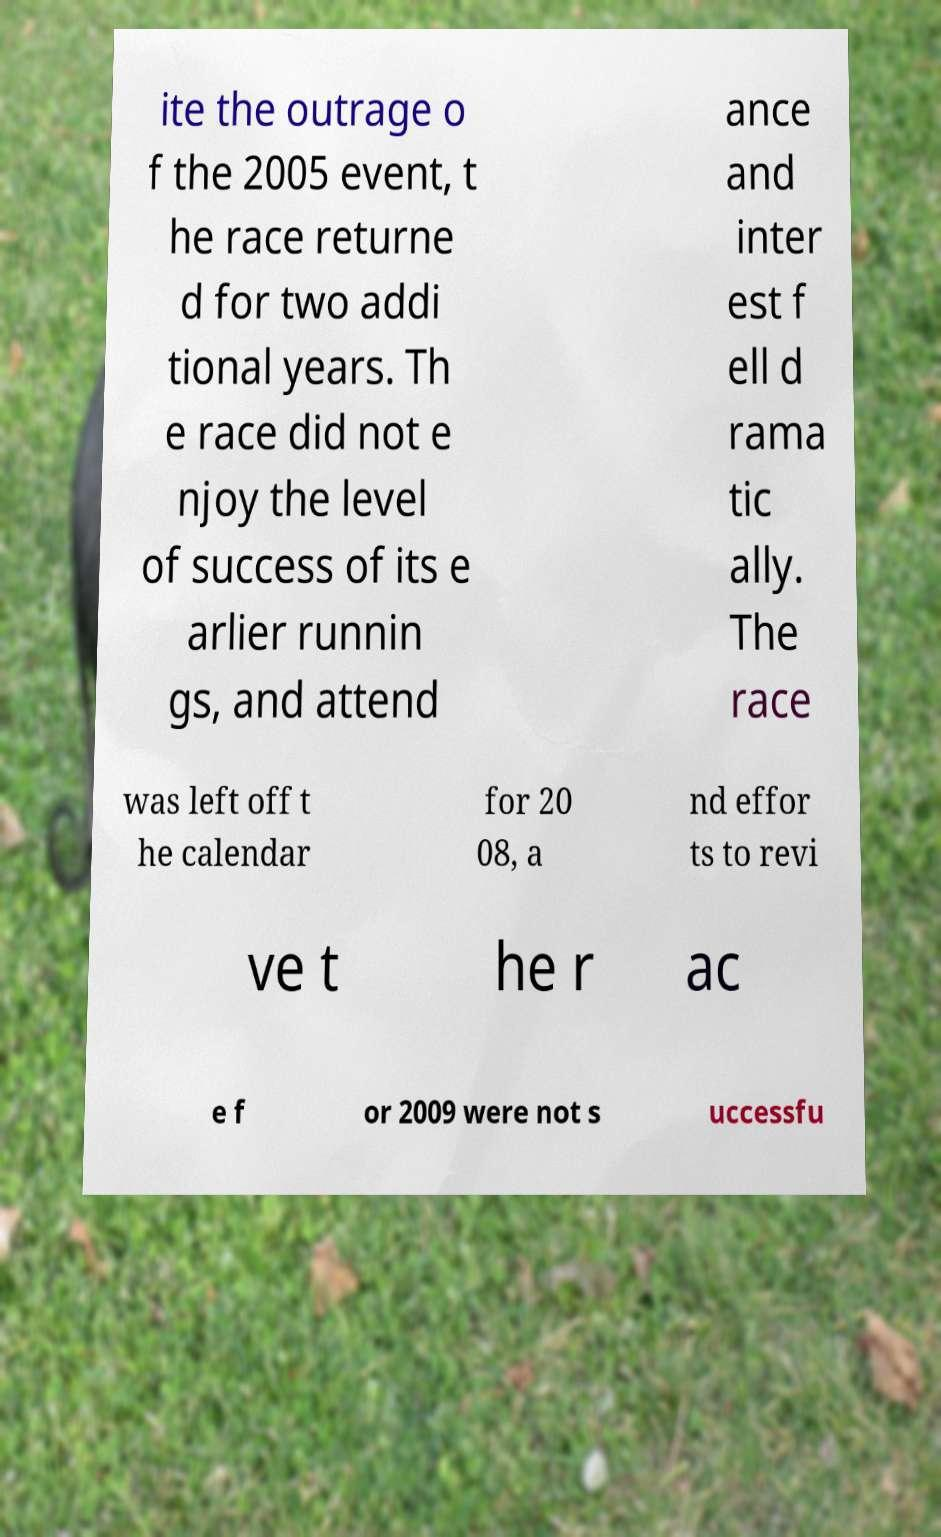Can you accurately transcribe the text from the provided image for me? ite the outrage o f the 2005 event, t he race returne d for two addi tional years. Th e race did not e njoy the level of success of its e arlier runnin gs, and attend ance and inter est f ell d rama tic ally. The race was left off t he calendar for 20 08, a nd effor ts to revi ve t he r ac e f or 2009 were not s uccessfu 